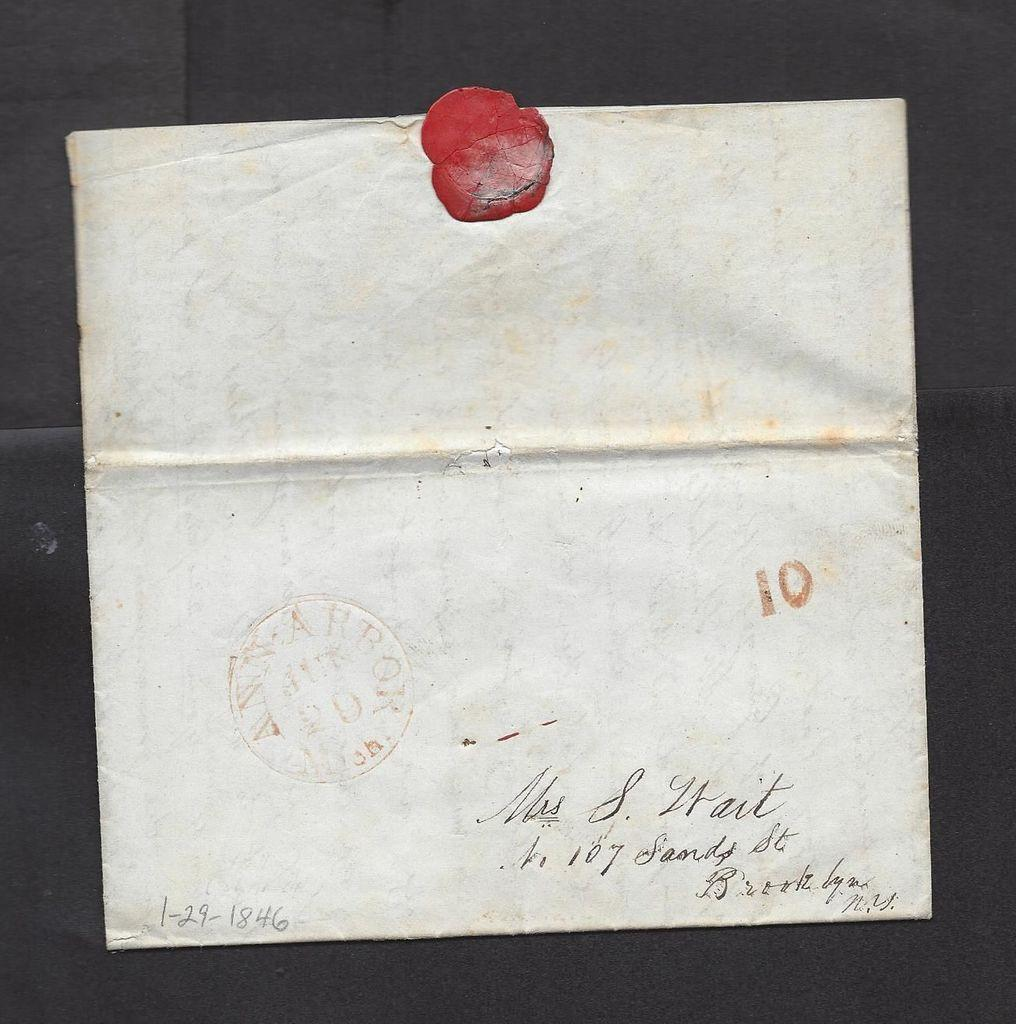Provide a one-sentence caption for the provided image. Signed letter that was written to someone back in 1846. 